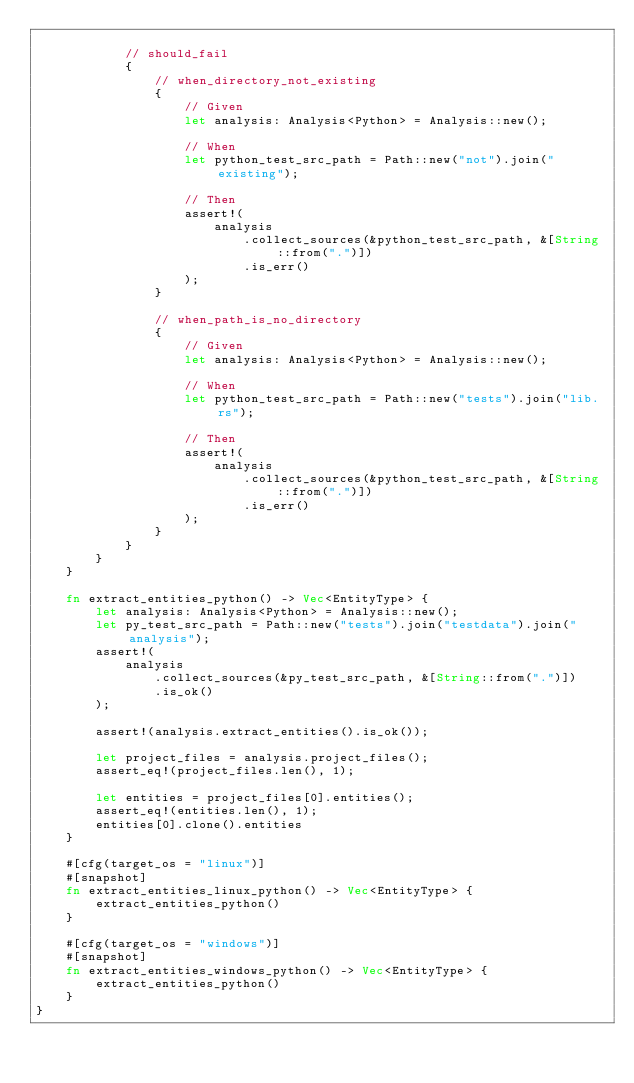<code> <loc_0><loc_0><loc_500><loc_500><_Rust_>
            // should_fail
            {
                // when_directory_not_existing
                {
                    // Given
                    let analysis: Analysis<Python> = Analysis::new();

                    // When
                    let python_test_src_path = Path::new("not").join("existing");

                    // Then
                    assert!(
                        analysis
                            .collect_sources(&python_test_src_path, &[String::from(".")])
                            .is_err()
                    );
                }

                // when_path_is_no_directory
                {
                    // Given
                    let analysis: Analysis<Python> = Analysis::new();

                    // When
                    let python_test_src_path = Path::new("tests").join("lib.rs");

                    // Then
                    assert!(
                        analysis
                            .collect_sources(&python_test_src_path, &[String::from(".")])
                            .is_err()
                    );
                }
            }
        }
    }

    fn extract_entities_python() -> Vec<EntityType> {
        let analysis: Analysis<Python> = Analysis::new();
        let py_test_src_path = Path::new("tests").join("testdata").join("analysis");
        assert!(
            analysis
                .collect_sources(&py_test_src_path, &[String::from(".")])
                .is_ok()
        );

        assert!(analysis.extract_entities().is_ok());

        let project_files = analysis.project_files();
        assert_eq!(project_files.len(), 1);

        let entities = project_files[0].entities();
        assert_eq!(entities.len(), 1);
        entities[0].clone().entities
    }

    #[cfg(target_os = "linux")]
    #[snapshot]
    fn extract_entities_linux_python() -> Vec<EntityType> {
        extract_entities_python()
    }

    #[cfg(target_os = "windows")]
    #[snapshot]
    fn extract_entities_windows_python() -> Vec<EntityType> {
        extract_entities_python()
    }
}
</code> 